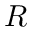<formula> <loc_0><loc_0><loc_500><loc_500>R</formula> 